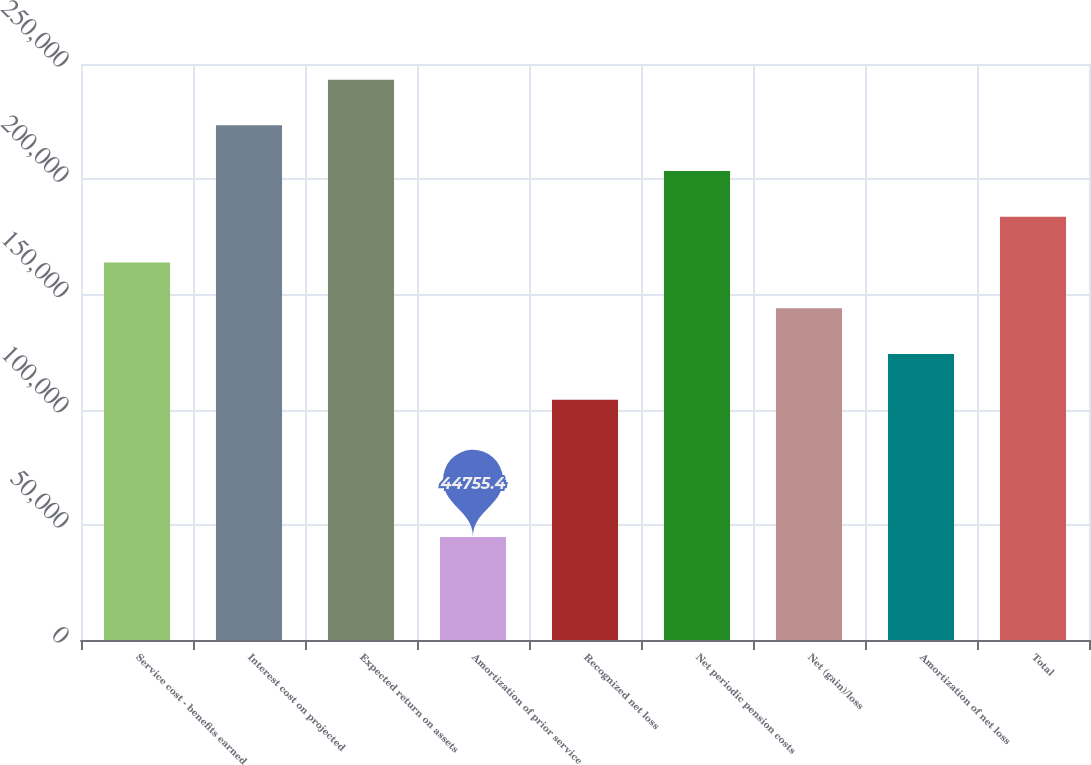Convert chart. <chart><loc_0><loc_0><loc_500><loc_500><bar_chart><fcel>Service cost - benefits earned<fcel>Interest cost on projected<fcel>Expected return on assets<fcel>Amortization of prior service<fcel>Recognized net loss<fcel>Net periodic pension costs<fcel>Net (gain)/loss<fcel>Amortization of net loss<fcel>Total<nl><fcel>163830<fcel>223367<fcel>243212<fcel>44755.4<fcel>104292<fcel>203521<fcel>143984<fcel>124138<fcel>183675<nl></chart> 